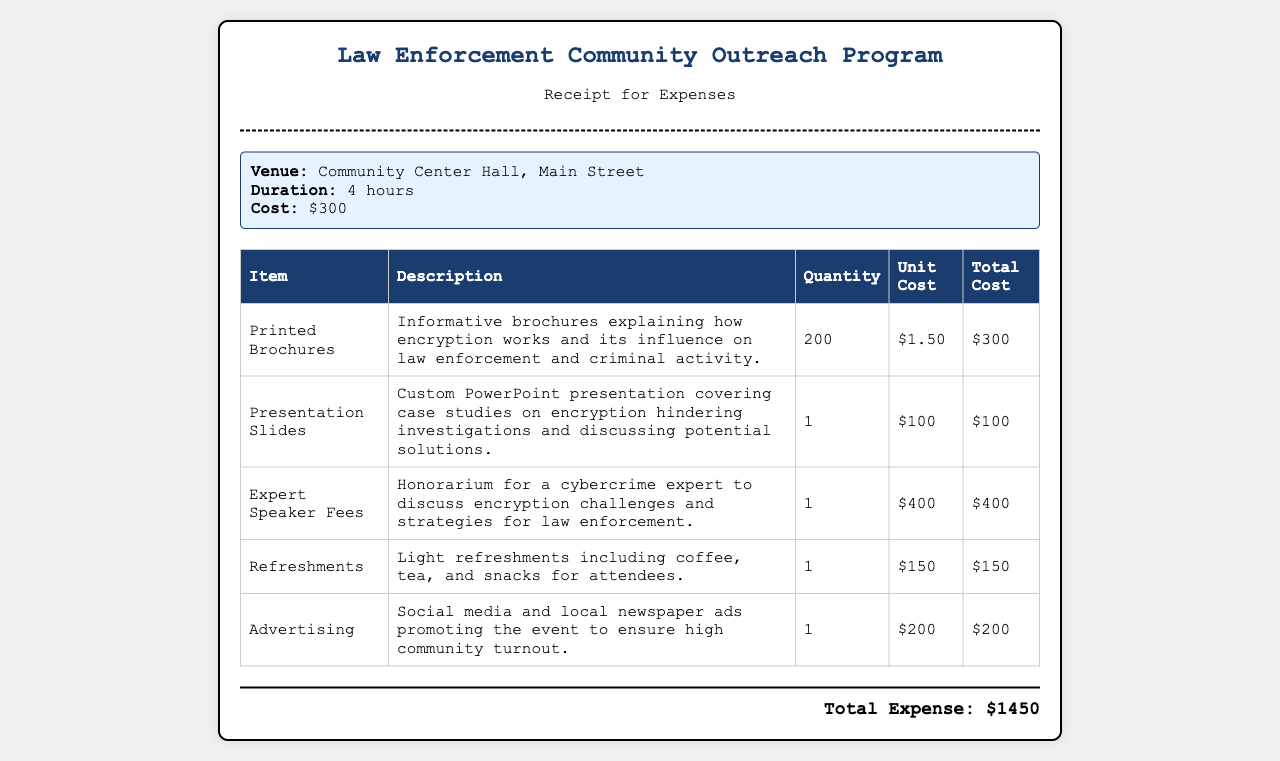What is the total cost of the venue? The venue cost is mentioned separately in the receipt, which indicates it is $300.
Answer: $300 How many printed brochures were prepared? The document specifies that 200 printed brochures were prepared for the outreach program.
Answer: 200 What is the cost of the expert speaker fees? The document lists the expert speaker fees as $400.
Answer: $400 What is the total expense for the outreach program? The total expense is calculated from the sum of all listed costs, which equals $1450.
Answer: $1450 What type of venue was used for the program? The document describes the venue as the Community Center Hall, Main Street.
Answer: Community Center Hall What was included in the refreshments? Light refreshments such as coffee, tea, and snacks were provided for attendees.
Answer: Coffee, tea, and snacks How many quantities of presentation slides were prepared? The document indicates there was only 1 presentation slide prepared for the event.
Answer: 1 What was the purpose of the printed brochures? The brochures aimed to explain how encryption works and its influence on law enforcement and criminal activity.
Answer: Explain encryption's influence What was the advertising budget for the event? The cost for advertising the event is listed as $200 in the document.
Answer: $200 